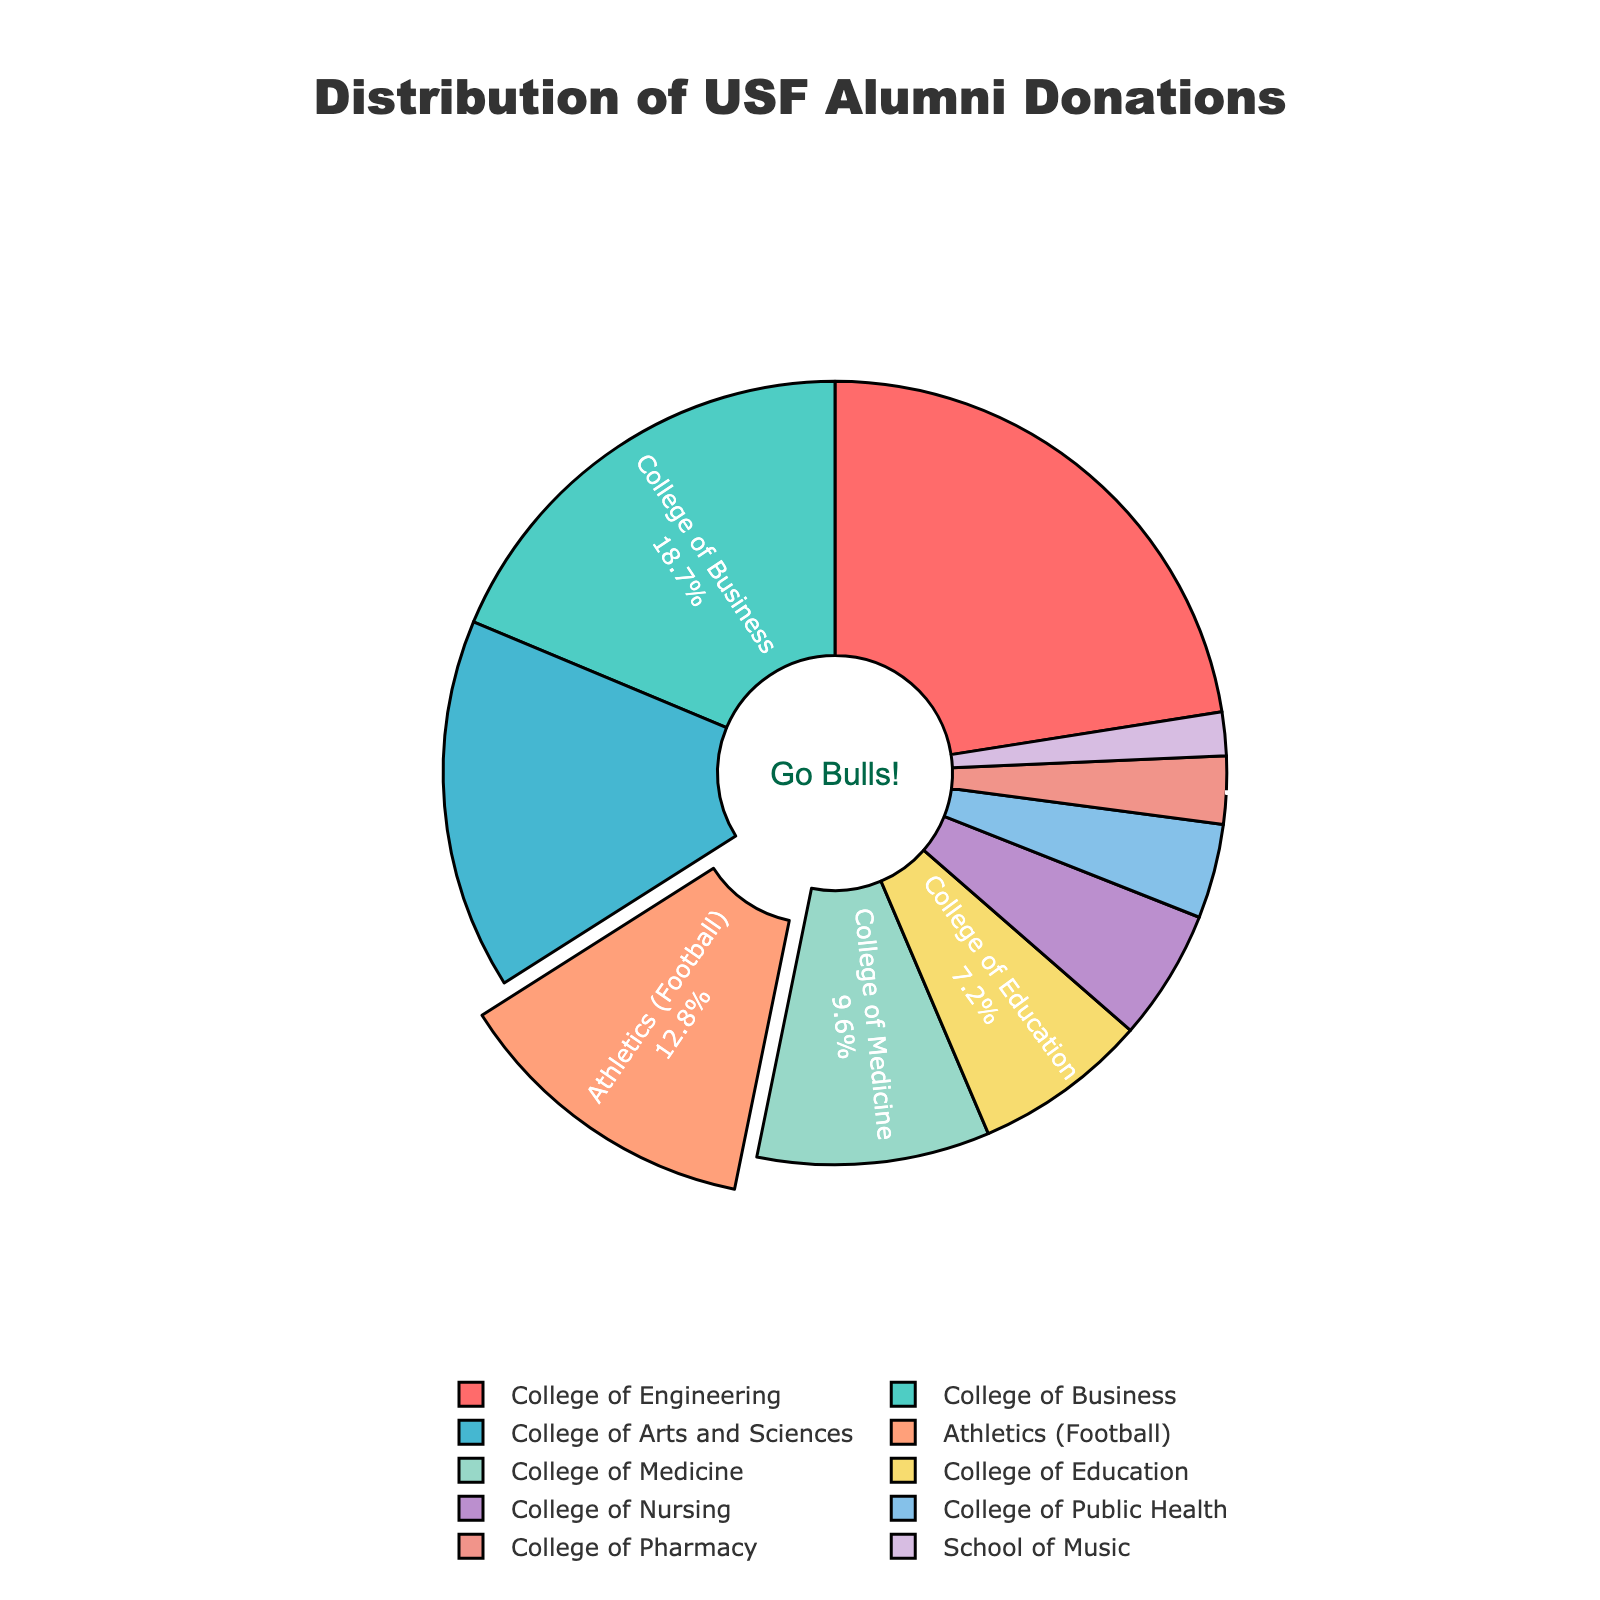what is the total donation percentage of the three highest contributing colleges or departments? The three highest contributing colleges or departments are the College of Engineering (22.5%), the College of Business (18.7%), and the College of Arts and Sciences (15.3%). Summing these percentages: 22.5 + 18.7 + 15.3 = 56.5%
Answer: 56.5% Which college or department received the lowest percentage of donations? According to the data, the School of Music received the lowest percentage of donations, which is 1.8%
Answer: School of Music How much more did the College of Engineering receive in donations compared to Athletics (Football)? The College of Engineering received 22.5% in donations, while Athletics (Football) received 12.8%. The difference is calculated as 22.5 - 12.8 = 9.7%
Answer: 9.7% What is the combined donation percentage for the College of Nursing and the College of Public Health? The College of Nursing received 5.4% and the College of Public Health received 3.9% in donations. Combined, this is 5.4 + 3.9 = 9.3%
Answer: 9.3% Which has a higher donation percentage, the College of Medicine or the College of Education, and by how much? The College of Medicine received 9.6%, while the College of Education received 7.2%. The College of Medicine has a higher donation percentage by 9.6 - 7.2 = 2.4%
Answer: College of Medicine by 2.4% What percentage of donations is represented by the colleges and departments that received less than 5% donations? The colleges and departments that received less than 5% are the College of Public Health (3.9%), College of Pharmacy (2.8%), and the School of Music (1.8%). Summing these: 3.9 + 2.8 + 1.8 = 8.5%
Answer: 8.5% Which segment in the pie chart is visually pulled out, and what does it signify? The segment for Athletics (Football) is visually pulled out. This signifies that the donations to Athletics (Football) are highlighted or emphasized in the figure
Answer: Athletics (Football) How does the donation percentage for the College of Business compare to that of the College of Arts and Sciences? The College of Business received 18.7% in donations, which is higher than the College of Arts and Sciences, which received 15.3%.
Answer: College of Business What is the average donation percentage for the College of Engineering, the College of Business, and the College of Arts and Sciences? These three colleges have donation percentages of 22.5%, 18.7%, and 15.3%, respectively. The average is calculated as (22.5 + 18.7 + 15.3) / 3 = 18.833%.
Answer: 18.83% What color represents the College of Nursing in the pie chart? In the pie chart, each sector is color-coded, and the College of Nursing is represented in a color that should correspond to the order given in the colors list from the code. Based on the coloring order mentioned, the College of Nursing is represented in a color (presumably based on the position in the list).
Answer: (Answer will depend on the execution but should follow the color order given in 'colors' array) 